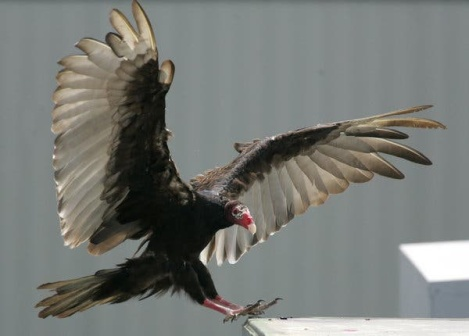Can you describe the scene in a poetic manner? Upon the roof’s edge, beneath a sky of endless blue, a solitary vulture spreads wings wide, in hues of black and brown, tipped with quiet white. Its crimson head, a beacon of primal grace, turns with ancient knowing, surveying the world below. Between earth and sky, it moves in timeless dance, a silent guardian of the heights. Against the building’s steadfast gray, its flight whispers of freedom, of journeys untold, painting the air with tales of boundless skies and the mysteries of soaring. 